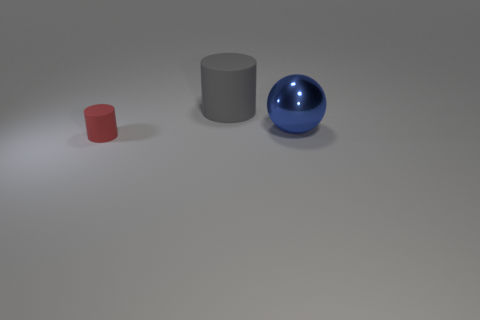Subtract all purple balls. Subtract all green cylinders. How many balls are left? 1 Add 2 matte objects. How many objects exist? 5 Subtract all balls. How many objects are left? 2 Subtract all tiny gray blocks. Subtract all large gray rubber cylinders. How many objects are left? 2 Add 3 balls. How many balls are left? 4 Add 2 big gray objects. How many big gray objects exist? 3 Subtract 0 yellow spheres. How many objects are left? 3 